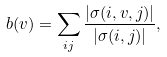Convert formula to latex. <formula><loc_0><loc_0><loc_500><loc_500>b ( v ) = \sum _ { i j } { \frac { \left | \sigma ( i , v , j ) \right | } { \left | \sigma ( i , j ) \right | } } ,</formula> 